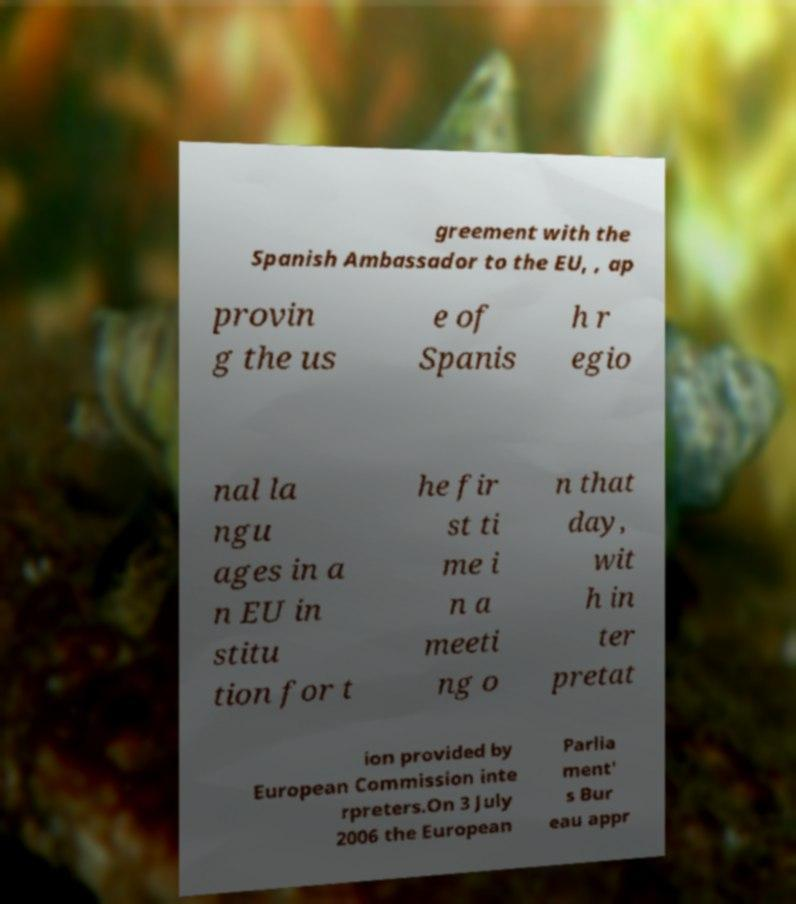I need the written content from this picture converted into text. Can you do that? greement with the Spanish Ambassador to the EU, , ap provin g the us e of Spanis h r egio nal la ngu ages in a n EU in stitu tion for t he fir st ti me i n a meeti ng o n that day, wit h in ter pretat ion provided by European Commission inte rpreters.On 3 July 2006 the European Parlia ment' s Bur eau appr 